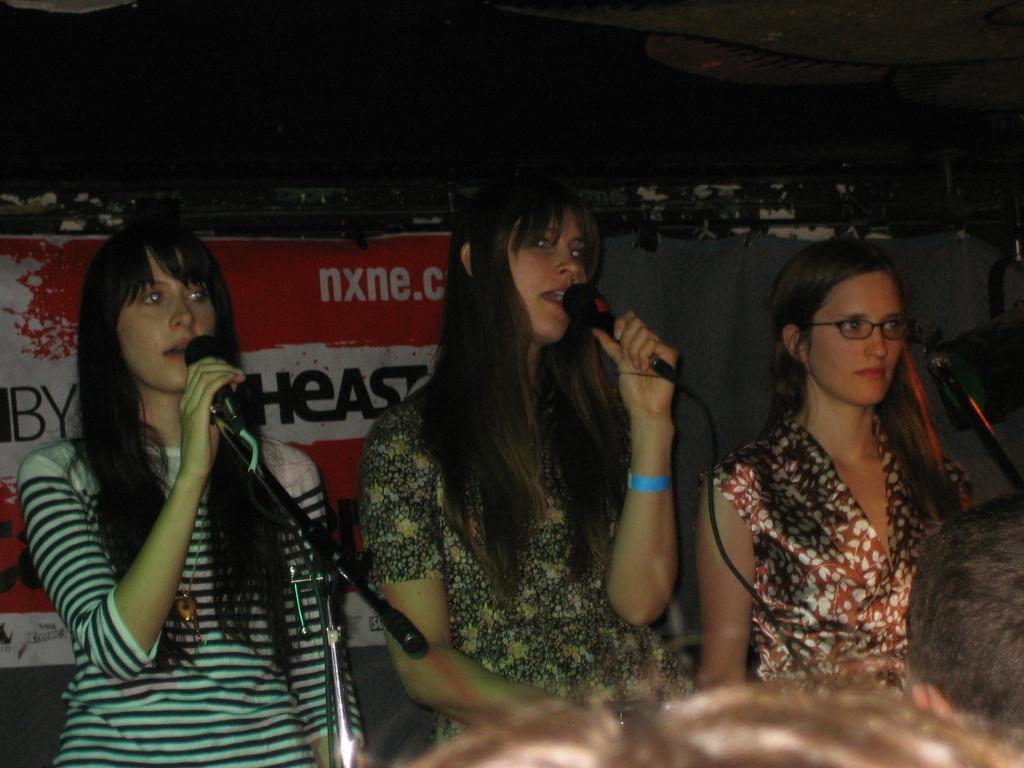In one or two sentences, can you explain what this image depicts? In this picture I can see three women who are holding the mic and they are singing. In the back I can see the poster which are placed on the wall. In the bottom I can see the women's hair. 